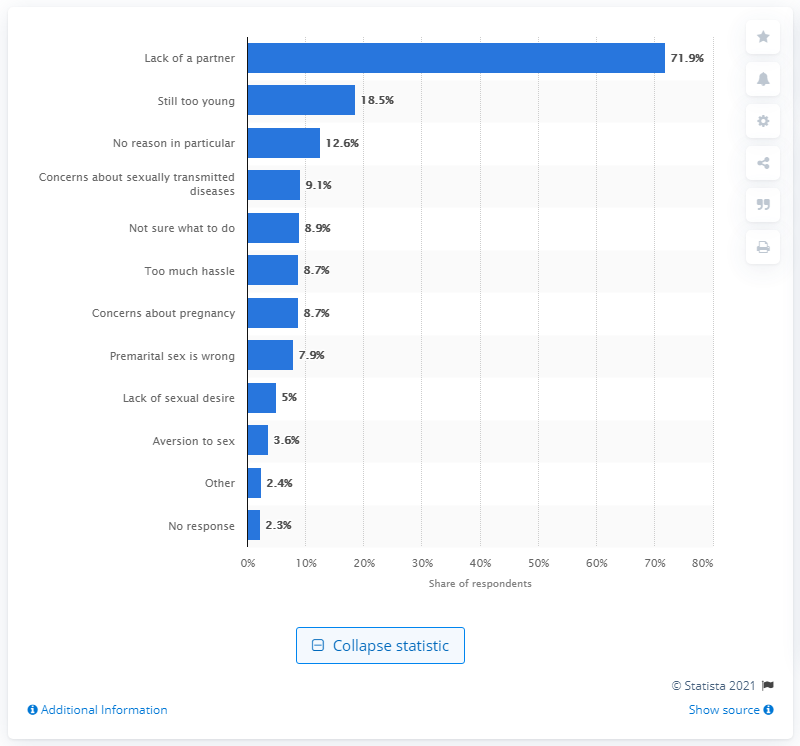Outline some significant characteristics in this image. According to the survey, 3.6% of male respondents reported aversion to sex as the main reason for not having sex yet. 